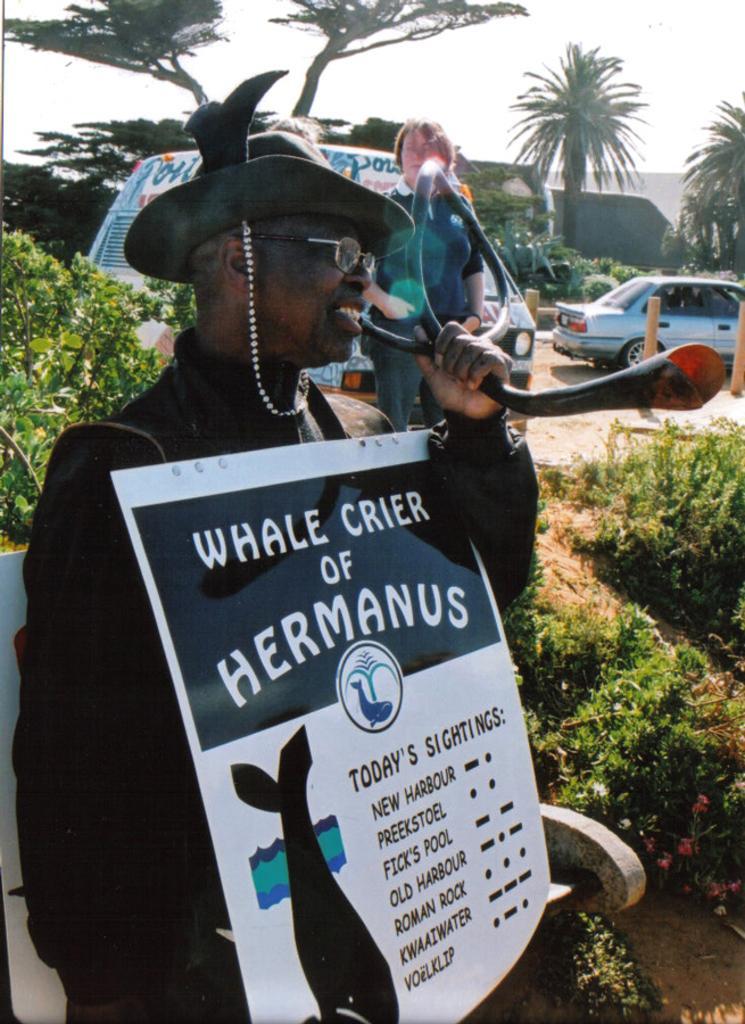Describe this image in one or two sentences. In this image there is a man in the middle who is holding the placard with one hand and a pipe with another hand. In the background there are vehicles on the ground. Behind them there are trees. On the left side there is a plant. 